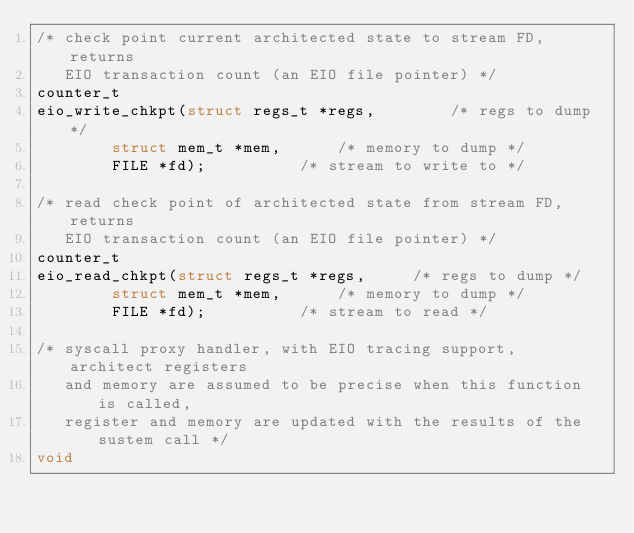<code> <loc_0><loc_0><loc_500><loc_500><_C_>/* check point current architected state to stream FD, returns
   EIO transaction count (an EIO file pointer) */
counter_t
eio_write_chkpt(struct regs_t *regs,		/* regs to dump */
		struct mem_t *mem,		/* memory to dump */
		FILE *fd);			/* stream to write to */

/* read check point of architected state from stream FD, returns
   EIO transaction count (an EIO file pointer) */
counter_t
eio_read_chkpt(struct regs_t *regs,		/* regs to dump */
		struct mem_t *mem,		/* memory to dump */
		FILE *fd);			/* stream to read */

/* syscall proxy handler, with EIO tracing support, architect registers
   and memory are assumed to be precise when this function is called,
   register and memory are updated with the results of the sustem call */
void</code> 